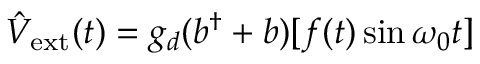Convert formula to latex. <formula><loc_0><loc_0><loc_500><loc_500>\hat { V } _ { e x t } ( t ) = g _ { d } ( b ^ { \dagger } + b ) [ f ( t ) \sin \omega _ { 0 } t ]</formula> 